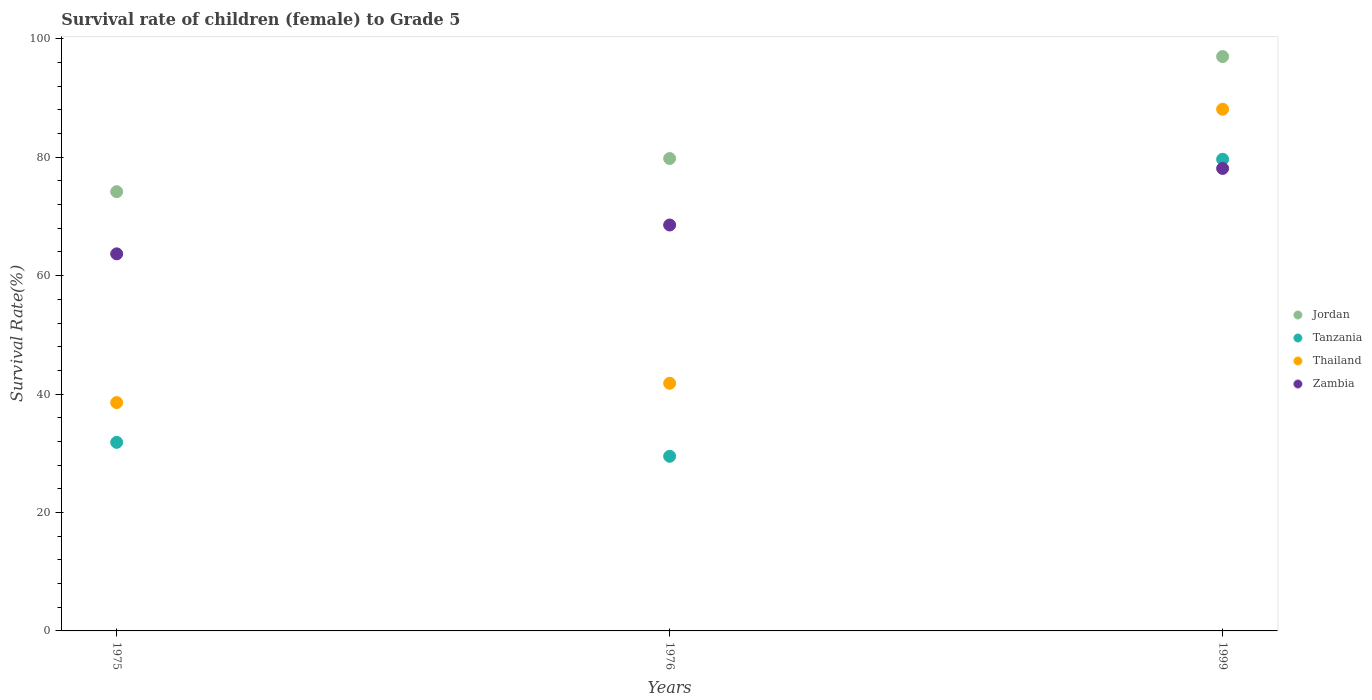How many different coloured dotlines are there?
Ensure brevity in your answer.  4. What is the survival rate of female children to grade 5 in Tanzania in 1999?
Keep it short and to the point. 79.65. Across all years, what is the maximum survival rate of female children to grade 5 in Thailand?
Offer a very short reply. 88.1. Across all years, what is the minimum survival rate of female children to grade 5 in Jordan?
Your answer should be compact. 74.18. In which year was the survival rate of female children to grade 5 in Thailand maximum?
Your answer should be very brief. 1999. In which year was the survival rate of female children to grade 5 in Tanzania minimum?
Provide a short and direct response. 1976. What is the total survival rate of female children to grade 5 in Jordan in the graph?
Provide a succinct answer. 250.96. What is the difference between the survival rate of female children to grade 5 in Zambia in 1975 and that in 1976?
Your answer should be very brief. -4.87. What is the difference between the survival rate of female children to grade 5 in Jordan in 1975 and the survival rate of female children to grade 5 in Thailand in 1976?
Offer a very short reply. 32.36. What is the average survival rate of female children to grade 5 in Jordan per year?
Keep it short and to the point. 83.65. In the year 1976, what is the difference between the survival rate of female children to grade 5 in Jordan and survival rate of female children to grade 5 in Zambia?
Provide a short and direct response. 11.23. In how many years, is the survival rate of female children to grade 5 in Tanzania greater than 96 %?
Ensure brevity in your answer.  0. What is the ratio of the survival rate of female children to grade 5 in Zambia in 1975 to that in 1999?
Your response must be concise. 0.82. Is the survival rate of female children to grade 5 in Thailand in 1975 less than that in 1976?
Keep it short and to the point. Yes. What is the difference between the highest and the second highest survival rate of female children to grade 5 in Zambia?
Offer a terse response. 9.55. What is the difference between the highest and the lowest survival rate of female children to grade 5 in Jordan?
Give a very brief answer. 22.82. Is it the case that in every year, the sum of the survival rate of female children to grade 5 in Zambia and survival rate of female children to grade 5 in Thailand  is greater than the sum of survival rate of female children to grade 5 in Tanzania and survival rate of female children to grade 5 in Jordan?
Provide a succinct answer. No. Is the survival rate of female children to grade 5 in Jordan strictly greater than the survival rate of female children to grade 5 in Zambia over the years?
Keep it short and to the point. Yes. Is the survival rate of female children to grade 5 in Tanzania strictly less than the survival rate of female children to grade 5 in Jordan over the years?
Your answer should be very brief. Yes. What is the difference between two consecutive major ticks on the Y-axis?
Your answer should be compact. 20. Are the values on the major ticks of Y-axis written in scientific E-notation?
Your answer should be compact. No. What is the title of the graph?
Provide a short and direct response. Survival rate of children (female) to Grade 5. Does "Morocco" appear as one of the legend labels in the graph?
Offer a very short reply. No. What is the label or title of the Y-axis?
Make the answer very short. Survival Rate(%). What is the Survival Rate(%) in Jordan in 1975?
Give a very brief answer. 74.18. What is the Survival Rate(%) in Tanzania in 1975?
Offer a very short reply. 31.85. What is the Survival Rate(%) of Thailand in 1975?
Give a very brief answer. 38.56. What is the Survival Rate(%) in Zambia in 1975?
Your response must be concise. 63.68. What is the Survival Rate(%) of Jordan in 1976?
Your response must be concise. 79.78. What is the Survival Rate(%) in Tanzania in 1976?
Give a very brief answer. 29.5. What is the Survival Rate(%) in Thailand in 1976?
Provide a succinct answer. 41.82. What is the Survival Rate(%) in Zambia in 1976?
Your answer should be very brief. 68.55. What is the Survival Rate(%) of Jordan in 1999?
Offer a terse response. 97. What is the Survival Rate(%) in Tanzania in 1999?
Provide a succinct answer. 79.65. What is the Survival Rate(%) in Thailand in 1999?
Your answer should be very brief. 88.1. What is the Survival Rate(%) in Zambia in 1999?
Keep it short and to the point. 78.1. Across all years, what is the maximum Survival Rate(%) of Jordan?
Keep it short and to the point. 97. Across all years, what is the maximum Survival Rate(%) in Tanzania?
Keep it short and to the point. 79.65. Across all years, what is the maximum Survival Rate(%) in Thailand?
Your answer should be very brief. 88.1. Across all years, what is the maximum Survival Rate(%) of Zambia?
Provide a short and direct response. 78.1. Across all years, what is the minimum Survival Rate(%) of Jordan?
Your answer should be compact. 74.18. Across all years, what is the minimum Survival Rate(%) in Tanzania?
Offer a terse response. 29.5. Across all years, what is the minimum Survival Rate(%) in Thailand?
Provide a succinct answer. 38.56. Across all years, what is the minimum Survival Rate(%) of Zambia?
Give a very brief answer. 63.68. What is the total Survival Rate(%) in Jordan in the graph?
Give a very brief answer. 250.96. What is the total Survival Rate(%) of Tanzania in the graph?
Provide a short and direct response. 140.99. What is the total Survival Rate(%) of Thailand in the graph?
Your answer should be compact. 168.49. What is the total Survival Rate(%) of Zambia in the graph?
Ensure brevity in your answer.  210.34. What is the difference between the Survival Rate(%) of Jordan in 1975 and that in 1976?
Offer a terse response. -5.6. What is the difference between the Survival Rate(%) of Tanzania in 1975 and that in 1976?
Keep it short and to the point. 2.35. What is the difference between the Survival Rate(%) in Thailand in 1975 and that in 1976?
Your answer should be compact. -3.26. What is the difference between the Survival Rate(%) of Zambia in 1975 and that in 1976?
Ensure brevity in your answer.  -4.87. What is the difference between the Survival Rate(%) of Jordan in 1975 and that in 1999?
Your response must be concise. -22.82. What is the difference between the Survival Rate(%) in Tanzania in 1975 and that in 1999?
Offer a terse response. -47.8. What is the difference between the Survival Rate(%) in Thailand in 1975 and that in 1999?
Provide a short and direct response. -49.54. What is the difference between the Survival Rate(%) in Zambia in 1975 and that in 1999?
Provide a short and direct response. -14.42. What is the difference between the Survival Rate(%) of Jordan in 1976 and that in 1999?
Make the answer very short. -17.22. What is the difference between the Survival Rate(%) of Tanzania in 1976 and that in 1999?
Provide a succinct answer. -50.16. What is the difference between the Survival Rate(%) in Thailand in 1976 and that in 1999?
Your answer should be very brief. -46.28. What is the difference between the Survival Rate(%) in Zambia in 1976 and that in 1999?
Provide a succinct answer. -9.55. What is the difference between the Survival Rate(%) in Jordan in 1975 and the Survival Rate(%) in Tanzania in 1976?
Offer a terse response. 44.69. What is the difference between the Survival Rate(%) of Jordan in 1975 and the Survival Rate(%) of Thailand in 1976?
Provide a succinct answer. 32.36. What is the difference between the Survival Rate(%) in Jordan in 1975 and the Survival Rate(%) in Zambia in 1976?
Offer a terse response. 5.63. What is the difference between the Survival Rate(%) of Tanzania in 1975 and the Survival Rate(%) of Thailand in 1976?
Your answer should be very brief. -9.98. What is the difference between the Survival Rate(%) of Tanzania in 1975 and the Survival Rate(%) of Zambia in 1976?
Offer a terse response. -36.71. What is the difference between the Survival Rate(%) of Thailand in 1975 and the Survival Rate(%) of Zambia in 1976?
Give a very brief answer. -29.99. What is the difference between the Survival Rate(%) of Jordan in 1975 and the Survival Rate(%) of Tanzania in 1999?
Your response must be concise. -5.47. What is the difference between the Survival Rate(%) of Jordan in 1975 and the Survival Rate(%) of Thailand in 1999?
Offer a terse response. -13.92. What is the difference between the Survival Rate(%) of Jordan in 1975 and the Survival Rate(%) of Zambia in 1999?
Offer a very short reply. -3.92. What is the difference between the Survival Rate(%) in Tanzania in 1975 and the Survival Rate(%) in Thailand in 1999?
Your response must be concise. -56.26. What is the difference between the Survival Rate(%) in Tanzania in 1975 and the Survival Rate(%) in Zambia in 1999?
Offer a terse response. -46.26. What is the difference between the Survival Rate(%) of Thailand in 1975 and the Survival Rate(%) of Zambia in 1999?
Offer a very short reply. -39.54. What is the difference between the Survival Rate(%) of Jordan in 1976 and the Survival Rate(%) of Tanzania in 1999?
Your answer should be compact. 0.13. What is the difference between the Survival Rate(%) of Jordan in 1976 and the Survival Rate(%) of Thailand in 1999?
Your response must be concise. -8.32. What is the difference between the Survival Rate(%) of Jordan in 1976 and the Survival Rate(%) of Zambia in 1999?
Your answer should be compact. 1.68. What is the difference between the Survival Rate(%) of Tanzania in 1976 and the Survival Rate(%) of Thailand in 1999?
Keep it short and to the point. -58.61. What is the difference between the Survival Rate(%) of Tanzania in 1976 and the Survival Rate(%) of Zambia in 1999?
Ensure brevity in your answer.  -48.61. What is the difference between the Survival Rate(%) of Thailand in 1976 and the Survival Rate(%) of Zambia in 1999?
Your answer should be compact. -36.28. What is the average Survival Rate(%) in Jordan per year?
Your response must be concise. 83.65. What is the average Survival Rate(%) of Tanzania per year?
Offer a terse response. 47. What is the average Survival Rate(%) of Thailand per year?
Your response must be concise. 56.16. What is the average Survival Rate(%) of Zambia per year?
Make the answer very short. 70.11. In the year 1975, what is the difference between the Survival Rate(%) in Jordan and Survival Rate(%) in Tanzania?
Your answer should be very brief. 42.34. In the year 1975, what is the difference between the Survival Rate(%) of Jordan and Survival Rate(%) of Thailand?
Make the answer very short. 35.62. In the year 1975, what is the difference between the Survival Rate(%) in Jordan and Survival Rate(%) in Zambia?
Provide a short and direct response. 10.5. In the year 1975, what is the difference between the Survival Rate(%) in Tanzania and Survival Rate(%) in Thailand?
Make the answer very short. -6.72. In the year 1975, what is the difference between the Survival Rate(%) of Tanzania and Survival Rate(%) of Zambia?
Give a very brief answer. -31.84. In the year 1975, what is the difference between the Survival Rate(%) of Thailand and Survival Rate(%) of Zambia?
Provide a short and direct response. -25.12. In the year 1976, what is the difference between the Survival Rate(%) of Jordan and Survival Rate(%) of Tanzania?
Provide a short and direct response. 50.28. In the year 1976, what is the difference between the Survival Rate(%) in Jordan and Survival Rate(%) in Thailand?
Make the answer very short. 37.96. In the year 1976, what is the difference between the Survival Rate(%) in Jordan and Survival Rate(%) in Zambia?
Ensure brevity in your answer.  11.23. In the year 1976, what is the difference between the Survival Rate(%) in Tanzania and Survival Rate(%) in Thailand?
Your answer should be very brief. -12.33. In the year 1976, what is the difference between the Survival Rate(%) of Tanzania and Survival Rate(%) of Zambia?
Provide a short and direct response. -39.06. In the year 1976, what is the difference between the Survival Rate(%) in Thailand and Survival Rate(%) in Zambia?
Ensure brevity in your answer.  -26.73. In the year 1999, what is the difference between the Survival Rate(%) of Jordan and Survival Rate(%) of Tanzania?
Provide a short and direct response. 17.35. In the year 1999, what is the difference between the Survival Rate(%) of Jordan and Survival Rate(%) of Thailand?
Offer a very short reply. 8.9. In the year 1999, what is the difference between the Survival Rate(%) of Jordan and Survival Rate(%) of Zambia?
Give a very brief answer. 18.9. In the year 1999, what is the difference between the Survival Rate(%) of Tanzania and Survival Rate(%) of Thailand?
Offer a terse response. -8.45. In the year 1999, what is the difference between the Survival Rate(%) of Tanzania and Survival Rate(%) of Zambia?
Keep it short and to the point. 1.55. In the year 1999, what is the difference between the Survival Rate(%) in Thailand and Survival Rate(%) in Zambia?
Provide a short and direct response. 10. What is the ratio of the Survival Rate(%) in Jordan in 1975 to that in 1976?
Offer a terse response. 0.93. What is the ratio of the Survival Rate(%) of Tanzania in 1975 to that in 1976?
Offer a very short reply. 1.08. What is the ratio of the Survival Rate(%) in Thailand in 1975 to that in 1976?
Offer a terse response. 0.92. What is the ratio of the Survival Rate(%) in Zambia in 1975 to that in 1976?
Provide a succinct answer. 0.93. What is the ratio of the Survival Rate(%) of Jordan in 1975 to that in 1999?
Your answer should be compact. 0.76. What is the ratio of the Survival Rate(%) in Tanzania in 1975 to that in 1999?
Offer a terse response. 0.4. What is the ratio of the Survival Rate(%) of Thailand in 1975 to that in 1999?
Your response must be concise. 0.44. What is the ratio of the Survival Rate(%) of Zambia in 1975 to that in 1999?
Provide a succinct answer. 0.82. What is the ratio of the Survival Rate(%) in Jordan in 1976 to that in 1999?
Provide a succinct answer. 0.82. What is the ratio of the Survival Rate(%) in Tanzania in 1976 to that in 1999?
Your answer should be very brief. 0.37. What is the ratio of the Survival Rate(%) in Thailand in 1976 to that in 1999?
Keep it short and to the point. 0.47. What is the ratio of the Survival Rate(%) of Zambia in 1976 to that in 1999?
Offer a terse response. 0.88. What is the difference between the highest and the second highest Survival Rate(%) of Jordan?
Offer a very short reply. 17.22. What is the difference between the highest and the second highest Survival Rate(%) of Tanzania?
Your answer should be compact. 47.8. What is the difference between the highest and the second highest Survival Rate(%) of Thailand?
Offer a terse response. 46.28. What is the difference between the highest and the second highest Survival Rate(%) of Zambia?
Your answer should be compact. 9.55. What is the difference between the highest and the lowest Survival Rate(%) in Jordan?
Offer a terse response. 22.82. What is the difference between the highest and the lowest Survival Rate(%) in Tanzania?
Your answer should be compact. 50.16. What is the difference between the highest and the lowest Survival Rate(%) of Thailand?
Offer a terse response. 49.54. What is the difference between the highest and the lowest Survival Rate(%) of Zambia?
Make the answer very short. 14.42. 